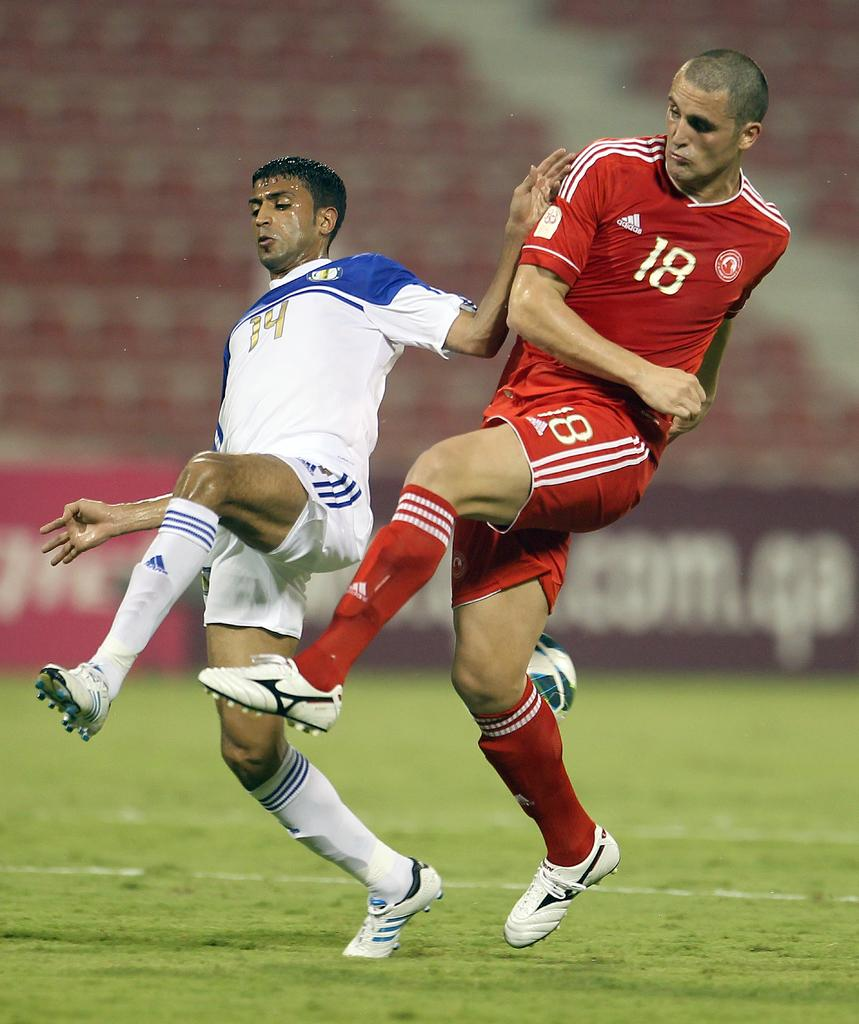Provide a one-sentence caption for the provided image. Players 14 and 18 from opposing soccer teams go for the ball. 